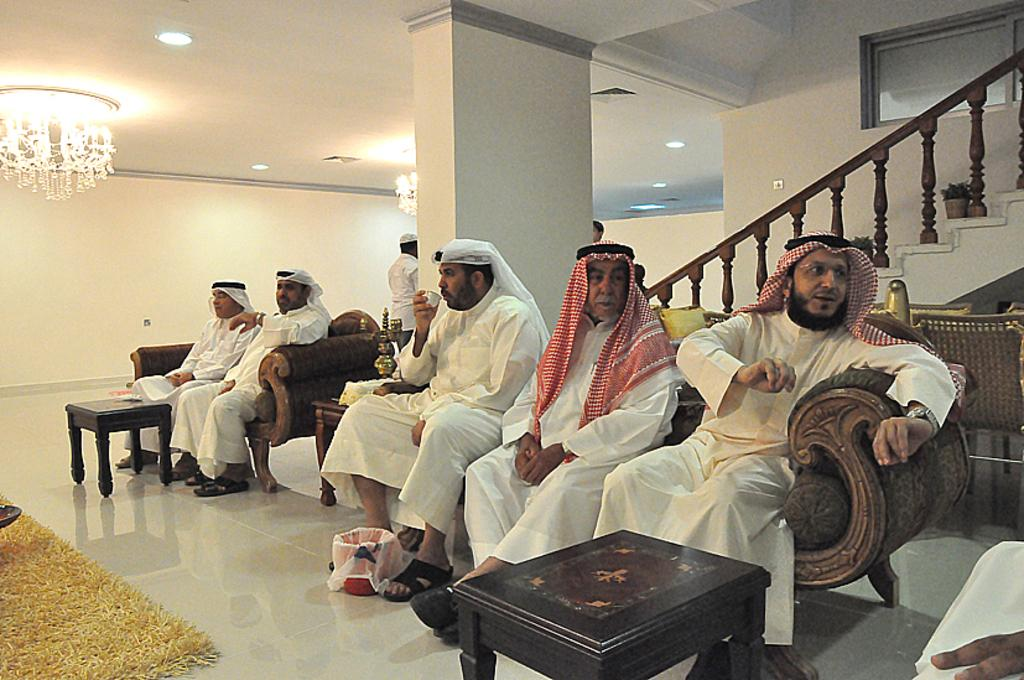What are the men in the image doing? The men are sitting on a sofa in the image. What architectural feature can be seen in the image? There are stairs visible in the image. What is located at the top of the stairs? There is a chandelier at the top of the stairs in the image. What type of pear is being used as a decoration on the chandelier? There is no pear present on the chandelier or in the image. 